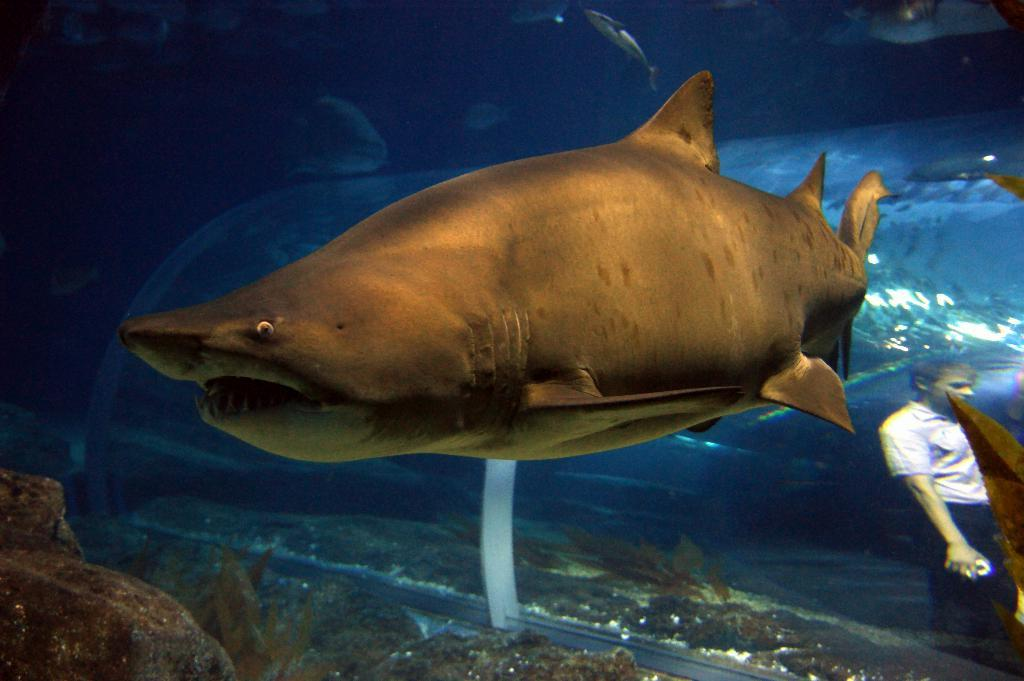What type of animals can be seen in the image? There are fishes and a shark in the image. Can you describe the person's reflection in the image? There is a person's reflection visible in the image. What type of downtown area can be seen in the image? There is no downtown area present in the image; it features fishes, a shark, and a person's reflection. What company is responsible for the van in the image? There is no van present in the image. 